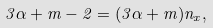<formula> <loc_0><loc_0><loc_500><loc_500>3 \alpha + m - 2 = ( 3 \alpha + m ) n _ { x } ,</formula> 